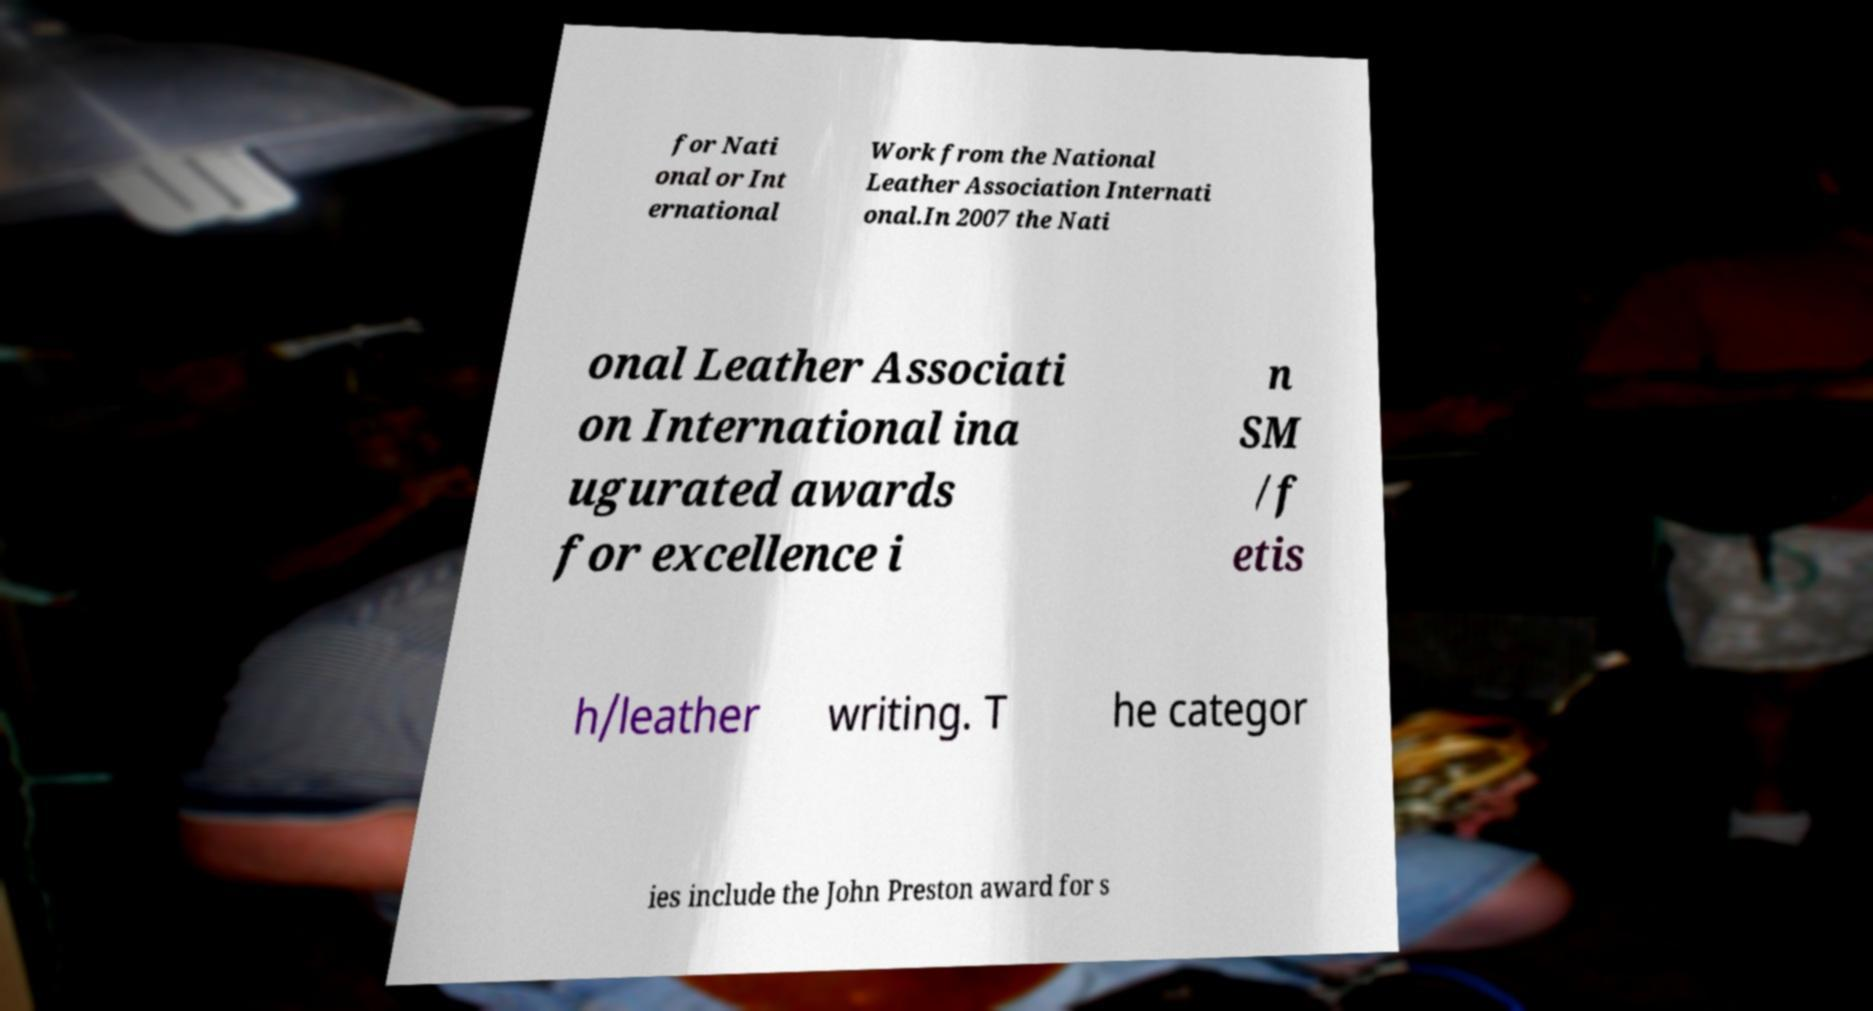Can you accurately transcribe the text from the provided image for me? for Nati onal or Int ernational Work from the National Leather Association Internati onal.In 2007 the Nati onal Leather Associati on International ina ugurated awards for excellence i n SM /f etis h/leather writing. T he categor ies include the John Preston award for s 